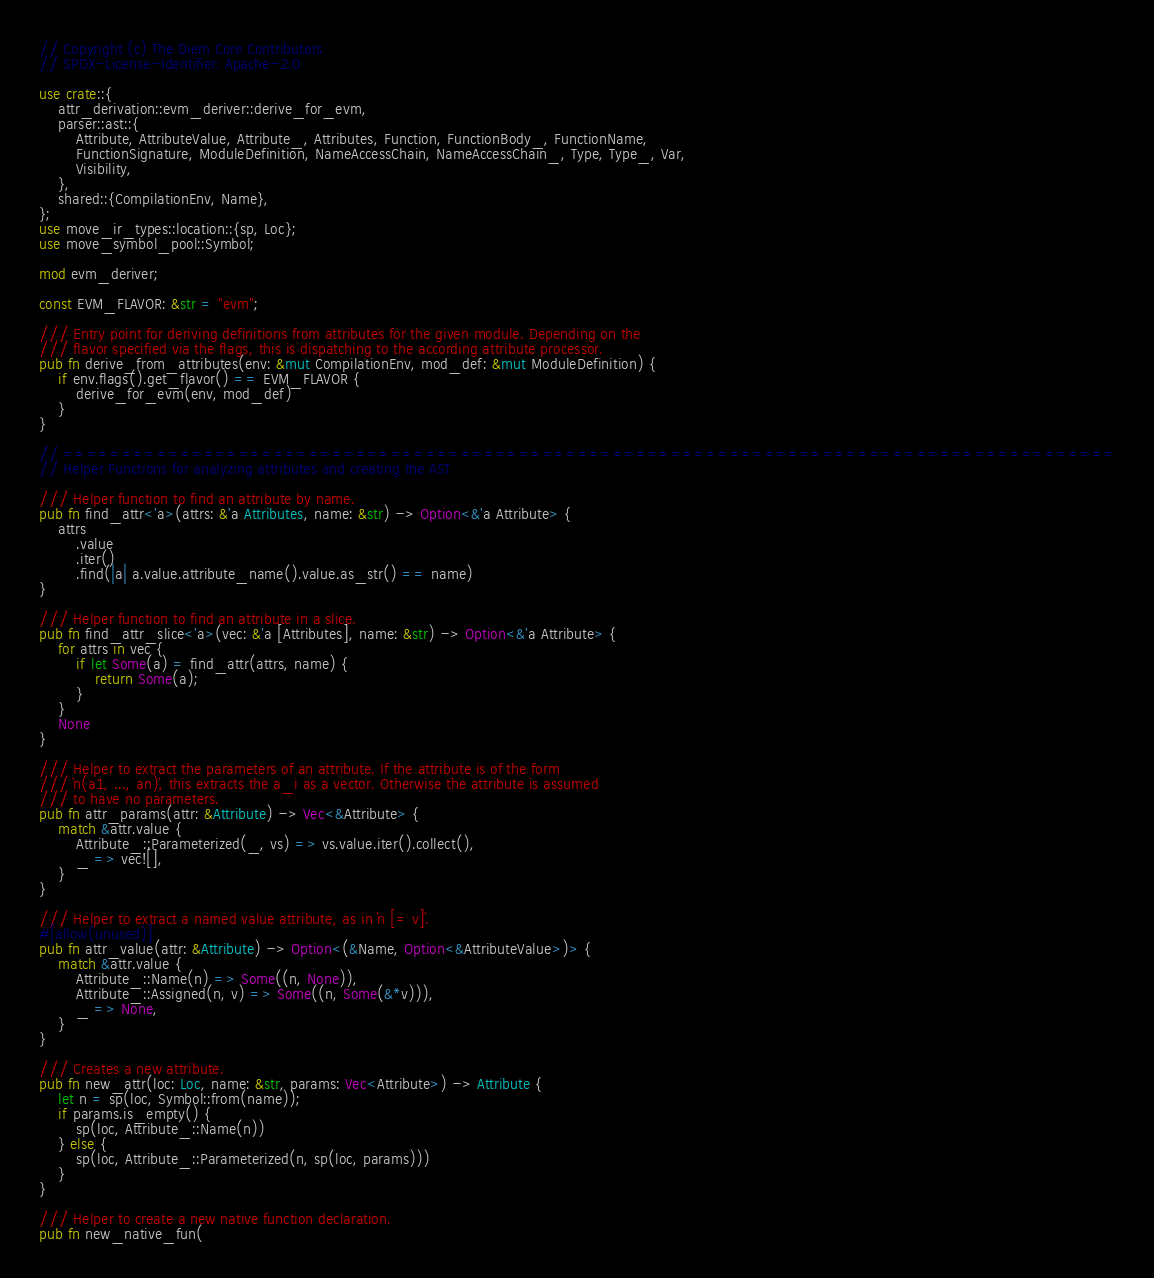Convert code to text. <code><loc_0><loc_0><loc_500><loc_500><_Rust_>// Copyright (c) The Diem Core Contributors
// SPDX-License-Identifier: Apache-2.0

use crate::{
    attr_derivation::evm_deriver::derive_for_evm,
    parser::ast::{
        Attribute, AttributeValue, Attribute_, Attributes, Function, FunctionBody_, FunctionName,
        FunctionSignature, ModuleDefinition, NameAccessChain, NameAccessChain_, Type, Type_, Var,
        Visibility,
    },
    shared::{CompilationEnv, Name},
};
use move_ir_types::location::{sp, Loc};
use move_symbol_pool::Symbol;

mod evm_deriver;

const EVM_FLAVOR: &str = "evm";

/// Entry point for deriving definitions from attributes for the given module. Depending on the
/// flavor specified via the flags, this is dispatching to the according attribute processor.
pub fn derive_from_attributes(env: &mut CompilationEnv, mod_def: &mut ModuleDefinition) {
    if env.flags().get_flavor() == EVM_FLAVOR {
        derive_for_evm(env, mod_def)
    }
}

// ==========================================================================================
// Helper Functions for analyzing attributes and creating the AST

/// Helper function to find an attribute by name.
pub fn find_attr<'a>(attrs: &'a Attributes, name: &str) -> Option<&'a Attribute> {
    attrs
        .value
        .iter()
        .find(|a| a.value.attribute_name().value.as_str() == name)
}

/// Helper function to find an attribute in a slice.
pub fn find_attr_slice<'a>(vec: &'a [Attributes], name: &str) -> Option<&'a Attribute> {
    for attrs in vec {
        if let Some(a) = find_attr(attrs, name) {
            return Some(a);
        }
    }
    None
}

/// Helper to extract the parameters of an attribute. If the attribute is of the form
/// `n(a1, ..., an)`, this extracts the a_i as a vector. Otherwise the attribute is assumed
/// to have no parameters.
pub fn attr_params(attr: &Attribute) -> Vec<&Attribute> {
    match &attr.value {
        Attribute_::Parameterized(_, vs) => vs.value.iter().collect(),
        _ => vec![],
    }
}

/// Helper to extract a named value attribute, as in `n [= v]`.
#[allow(unused)]
pub fn attr_value(attr: &Attribute) -> Option<(&Name, Option<&AttributeValue>)> {
    match &attr.value {
        Attribute_::Name(n) => Some((n, None)),
        Attribute_::Assigned(n, v) => Some((n, Some(&*v))),
        _ => None,
    }
}

/// Creates a new attribute.
pub fn new_attr(loc: Loc, name: &str, params: Vec<Attribute>) -> Attribute {
    let n = sp(loc, Symbol::from(name));
    if params.is_empty() {
        sp(loc, Attribute_::Name(n))
    } else {
        sp(loc, Attribute_::Parameterized(n, sp(loc, params)))
    }
}

/// Helper to create a new native function declaration.
pub fn new_native_fun(</code> 